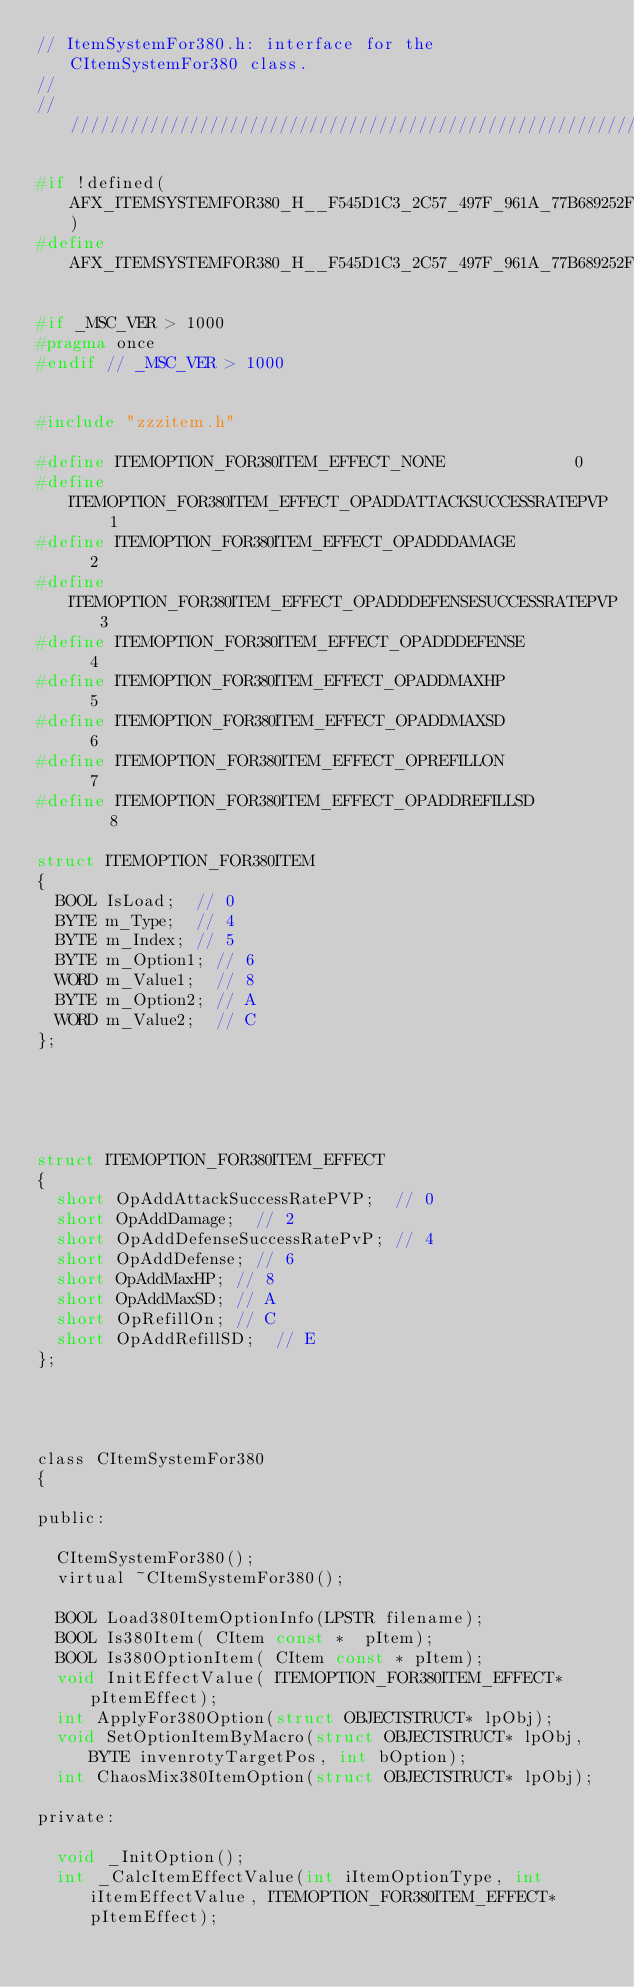<code> <loc_0><loc_0><loc_500><loc_500><_C_>// ItemSystemFor380.h: interface for the CItemSystemFor380 class.
//
//////////////////////////////////////////////////////////////////////

#if !defined(AFX_ITEMSYSTEMFOR380_H__F545D1C3_2C57_497F_961A_77B689252FFE__INCLUDED_)
#define AFX_ITEMSYSTEMFOR380_H__F545D1C3_2C57_497F_961A_77B689252FFE__INCLUDED_

#if _MSC_VER > 1000
#pragma once
#endif // _MSC_VER > 1000


#include "zzzitem.h"

#define ITEMOPTION_FOR380ITEM_EFFECT_NONE							0
#define ITEMOPTION_FOR380ITEM_EFFECT_OPADDATTACKSUCCESSRATEPVP		1
#define ITEMOPTION_FOR380ITEM_EFFECT_OPADDDAMAGE					2
#define ITEMOPTION_FOR380ITEM_EFFECT_OPADDDEFENSESUCCESSRATEPVP		3
#define ITEMOPTION_FOR380ITEM_EFFECT_OPADDDEFENSE					4
#define ITEMOPTION_FOR380ITEM_EFFECT_OPADDMAXHP						5
#define ITEMOPTION_FOR380ITEM_EFFECT_OPADDMAXSD						6
#define ITEMOPTION_FOR380ITEM_EFFECT_OPREFILLON						7
#define ITEMOPTION_FOR380ITEM_EFFECT_OPADDREFILLSD					8

struct ITEMOPTION_FOR380ITEM
{
	BOOL IsLoad;	// 0
	BYTE m_Type;	// 4
	BYTE m_Index;	// 5
	BYTE m_Option1;	// 6
	WORD m_Value1;	// 8
	BYTE m_Option2;	// A
	WORD m_Value2;	// C
};





struct ITEMOPTION_FOR380ITEM_EFFECT
{
	short OpAddAttackSuccessRatePVP;	// 0
	short OpAddDamage;	// 2
	short OpAddDefenseSuccessRatePvP;	// 4
	short OpAddDefense;	// 6
	short OpAddMaxHP;	// 8
	short OpAddMaxSD;	// A
	short OpRefillOn;	// C
	short OpAddRefillSD;	// E
};




class CItemSystemFor380
{

public:

	CItemSystemFor380();
	virtual ~CItemSystemFor380();

	BOOL Load380ItemOptionInfo(LPSTR filename);
	BOOL Is380Item( CItem const *  pItem);
	BOOL Is380OptionItem( CItem const * pItem);
	void InitEffectValue( ITEMOPTION_FOR380ITEM_EFFECT* pItemEffect);
	int ApplyFor380Option(struct OBJECTSTRUCT* lpObj);
	void SetOptionItemByMacro(struct OBJECTSTRUCT* lpObj, BYTE invenrotyTargetPos, int bOption);
	int ChaosMix380ItemOption(struct OBJECTSTRUCT* lpObj);

private:

	void _InitOption();
	int _CalcItemEffectValue(int iItemOptionType, int iItemEffectValue, ITEMOPTION_FOR380ITEM_EFFECT* pItemEffect);</code> 